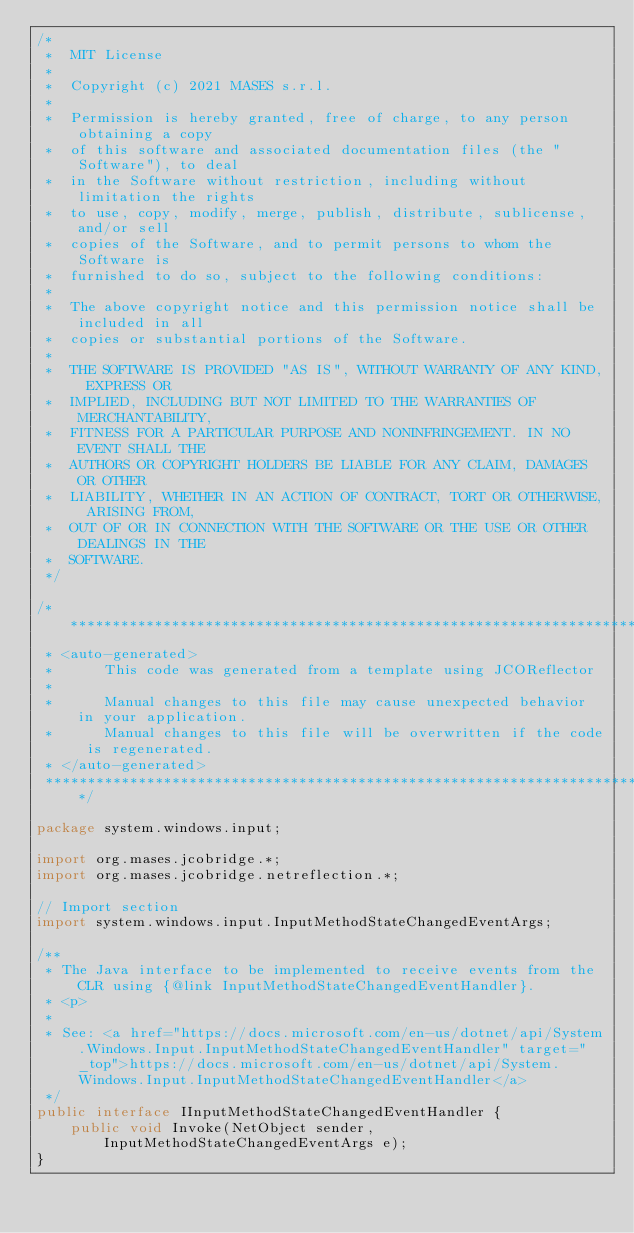<code> <loc_0><loc_0><loc_500><loc_500><_Java_>/*
 *  MIT License
 *
 *  Copyright (c) 2021 MASES s.r.l.
 *
 *  Permission is hereby granted, free of charge, to any person obtaining a copy
 *  of this software and associated documentation files (the "Software"), to deal
 *  in the Software without restriction, including without limitation the rights
 *  to use, copy, modify, merge, publish, distribute, sublicense, and/or sell
 *  copies of the Software, and to permit persons to whom the Software is
 *  furnished to do so, subject to the following conditions:
 *
 *  The above copyright notice and this permission notice shall be included in all
 *  copies or substantial portions of the Software.
 *
 *  THE SOFTWARE IS PROVIDED "AS IS", WITHOUT WARRANTY OF ANY KIND, EXPRESS OR
 *  IMPLIED, INCLUDING BUT NOT LIMITED TO THE WARRANTIES OF MERCHANTABILITY,
 *  FITNESS FOR A PARTICULAR PURPOSE AND NONINFRINGEMENT. IN NO EVENT SHALL THE
 *  AUTHORS OR COPYRIGHT HOLDERS BE LIABLE FOR ANY CLAIM, DAMAGES OR OTHER
 *  LIABILITY, WHETHER IN AN ACTION OF CONTRACT, TORT OR OTHERWISE, ARISING FROM,
 *  OUT OF OR IN CONNECTION WITH THE SOFTWARE OR THE USE OR OTHER DEALINGS IN THE
 *  SOFTWARE.
 */

/**************************************************************************************
 * <auto-generated>
 *      This code was generated from a template using JCOReflector
 * 
 *      Manual changes to this file may cause unexpected behavior in your application.
 *      Manual changes to this file will be overwritten if the code is regenerated.
 * </auto-generated>
 *************************************************************************************/

package system.windows.input;

import org.mases.jcobridge.*;
import org.mases.jcobridge.netreflection.*;

// Import section
import system.windows.input.InputMethodStateChangedEventArgs;

/**
 * The Java interface to be implemented to receive events from the CLR using {@link InputMethodStateChangedEventHandler}.
 * <p>
 * 
 * See: <a href="https://docs.microsoft.com/en-us/dotnet/api/System.Windows.Input.InputMethodStateChangedEventHandler" target="_top">https://docs.microsoft.com/en-us/dotnet/api/System.Windows.Input.InputMethodStateChangedEventHandler</a>
 */
public interface IInputMethodStateChangedEventHandler {
    public void Invoke(NetObject sender, InputMethodStateChangedEventArgs e);
}</code> 